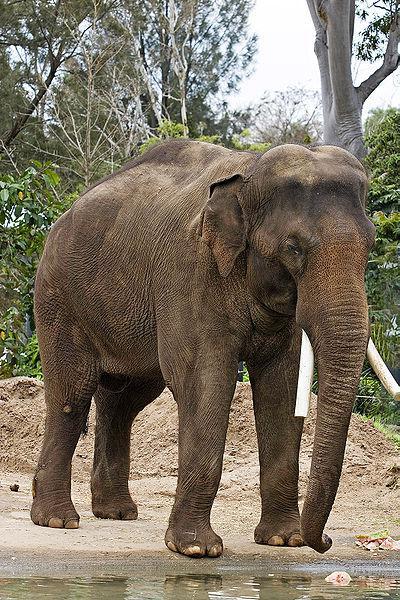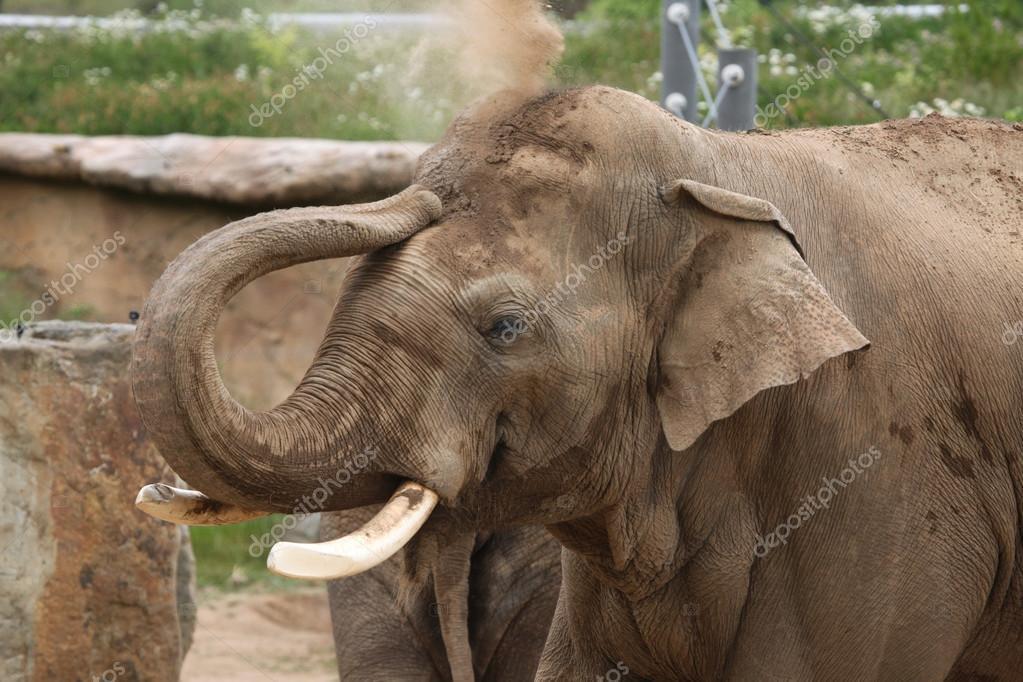The first image is the image on the left, the second image is the image on the right. Assess this claim about the two images: "An image shows a close group of exactly four elephants and includes animals of different ages.". Correct or not? Answer yes or no. No. The first image is the image on the left, the second image is the image on the right. Analyze the images presented: Is the assertion "There is one elephant in green grass in the image on the left." valid? Answer yes or no. No. 